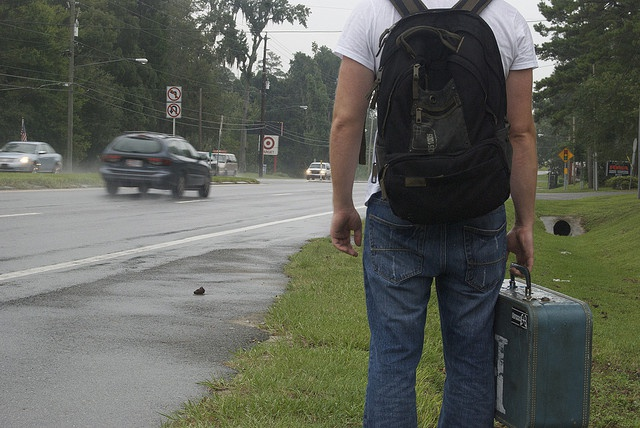Describe the objects in this image and their specific colors. I can see people in black, gray, and lightgray tones, backpack in black and gray tones, suitcase in black, gray, and purple tones, car in black, gray, and darkgray tones, and car in black, darkgray, gray, and lightgray tones in this image. 